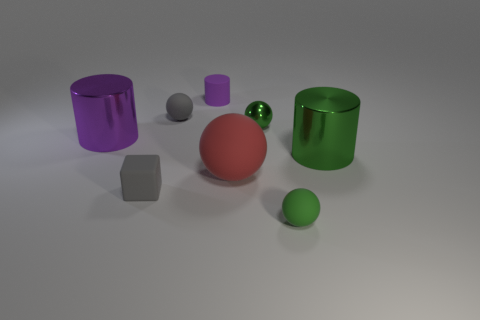There is a matte object that is the same color as the tiny block; what is its size?
Keep it short and to the point. Small. There is a big metal thing that is the same color as the small cylinder; what shape is it?
Provide a succinct answer. Cylinder. Do the small cylinder and the large metal object right of the large purple object have the same color?
Your answer should be compact. No. What number of other things are the same material as the small purple thing?
Provide a succinct answer. 4. Is the number of tiny spheres greater than the number of small green balls?
Offer a terse response. Yes. There is a object that is to the right of the green rubber sphere; does it have the same color as the small shiny sphere?
Your response must be concise. Yes. What color is the small metal object?
Offer a very short reply. Green. There is a metallic object to the left of the big sphere; is there a tiny green thing behind it?
Your response must be concise. Yes. What is the shape of the gray matte thing left of the tiny gray matte thing behind the tiny gray matte block?
Make the answer very short. Cube. Is the number of tiny matte objects less than the number of small green matte balls?
Your response must be concise. No. 